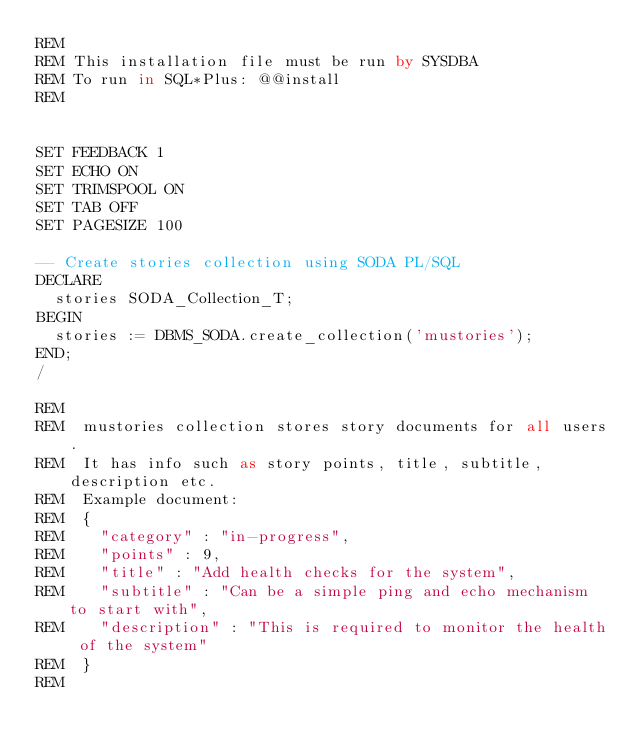Convert code to text. <code><loc_0><loc_0><loc_500><loc_500><_SQL_>REM
REM This installation file must be run by SYSDBA
REM To run in SQL*Plus: @@install
REM


SET FEEDBACK 1
SET ECHO ON
SET TRIMSPOOL ON
SET TAB OFF
SET PAGESIZE 100

-- Create stories collection using SODA PL/SQL
DECLARE
  stories SODA_Collection_T;
BEGIN
  stories := DBMS_SODA.create_collection('mustories');
END;
/

REM
REM  mustories collection stores story documents for all users.
REM  It has info such as story points, title, subtitle, description etc.
REM  Example document:
REM  {
REM    "category" : "in-progress",
REM    "points" : 9,
REM    "title" : "Add health checks for the system",
REM    "subtitle" : "Can be a simple ping and echo mechanism to start with",
REM    "description" : "This is required to monitor the health of the system"
REM  }
REM


</code> 